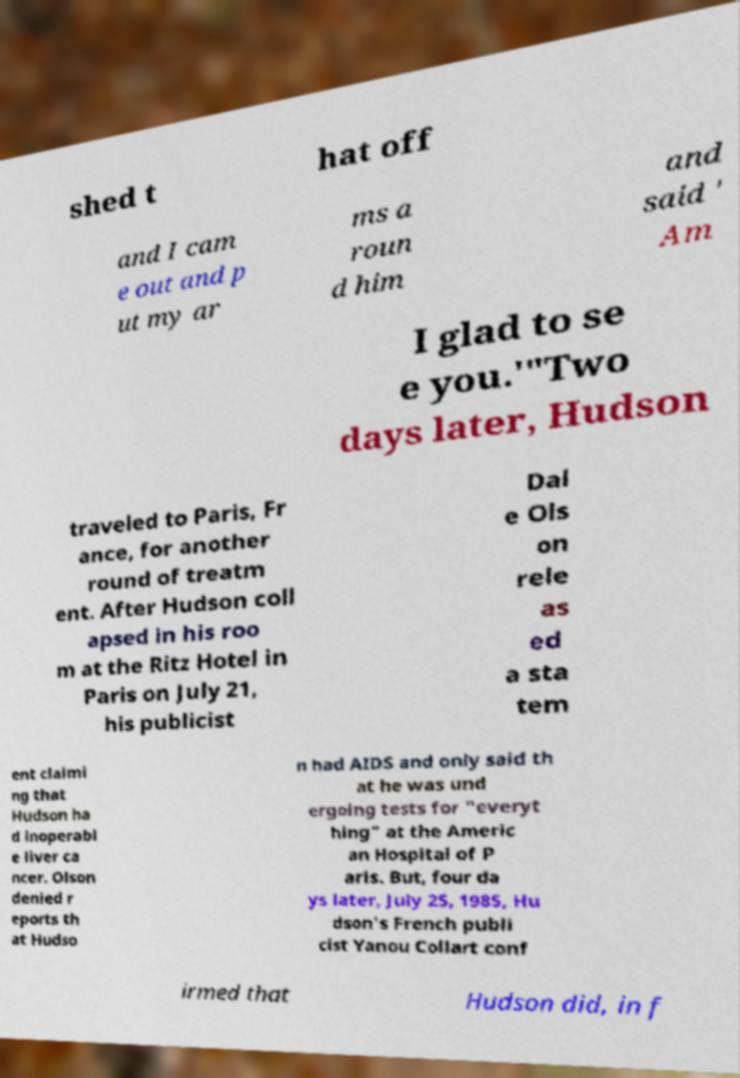Can you accurately transcribe the text from the provided image for me? shed t hat off and I cam e out and p ut my ar ms a roun d him and said ' Am I glad to se e you.'"Two days later, Hudson traveled to Paris, Fr ance, for another round of treatm ent. After Hudson coll apsed in his roo m at the Ritz Hotel in Paris on July 21, his publicist Dal e Ols on rele as ed a sta tem ent claimi ng that Hudson ha d inoperabl e liver ca ncer. Olson denied r eports th at Hudso n had AIDS and only said th at he was und ergoing tests for "everyt hing" at the Americ an Hospital of P aris. But, four da ys later, July 25, 1985, Hu dson's French publi cist Yanou Collart conf irmed that Hudson did, in f 